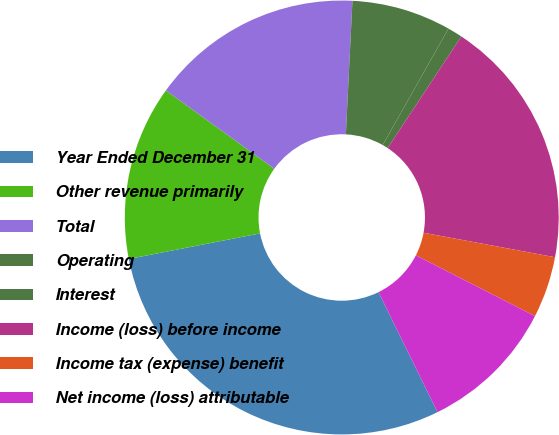Convert chart to OTSL. <chart><loc_0><loc_0><loc_500><loc_500><pie_chart><fcel>Year Ended December 31<fcel>Other revenue primarily<fcel>Total<fcel>Operating<fcel>Interest<fcel>Income (loss) before income<fcel>Income tax (expense) benefit<fcel>Net income (loss) attributable<nl><fcel>29.22%<fcel>13.02%<fcel>15.83%<fcel>7.4%<fcel>1.11%<fcel>18.64%<fcel>4.58%<fcel>10.21%<nl></chart> 